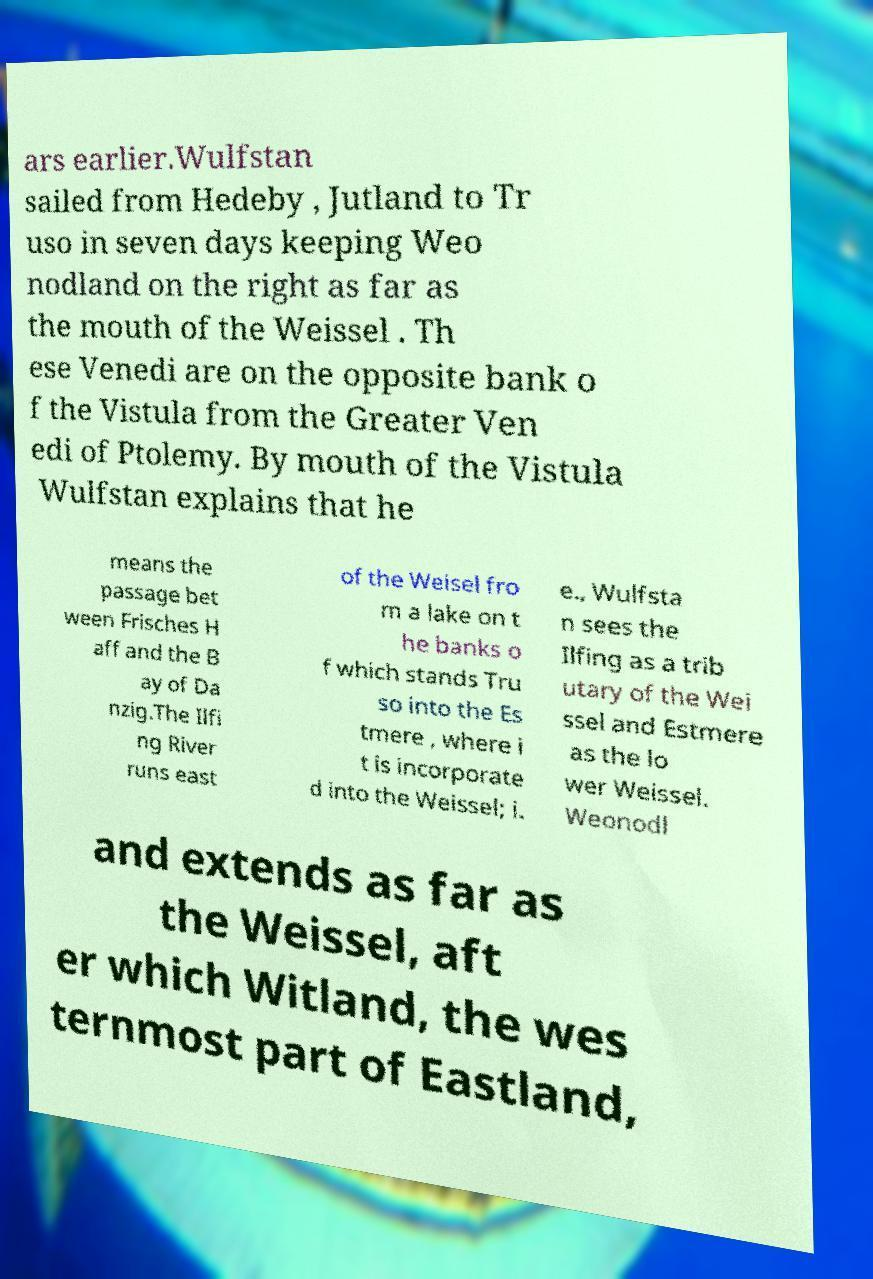Can you read and provide the text displayed in the image?This photo seems to have some interesting text. Can you extract and type it out for me? ars earlier.Wulfstan sailed from Hedeby , Jutland to Tr uso in seven days keeping Weo nodland on the right as far as the mouth of the Weissel . Th ese Venedi are on the opposite bank o f the Vistula from the Greater Ven edi of Ptolemy. By mouth of the Vistula Wulfstan explains that he means the passage bet ween Frisches H aff and the B ay of Da nzig.The Ilfi ng River runs east of the Weisel fro m a lake on t he banks o f which stands Tru so into the Es tmere , where i t is incorporate d into the Weissel; i. e., Wulfsta n sees the Ilfing as a trib utary of the Wei ssel and Estmere as the lo wer Weissel. Weonodl and extends as far as the Weissel, aft er which Witland, the wes ternmost part of Eastland, 